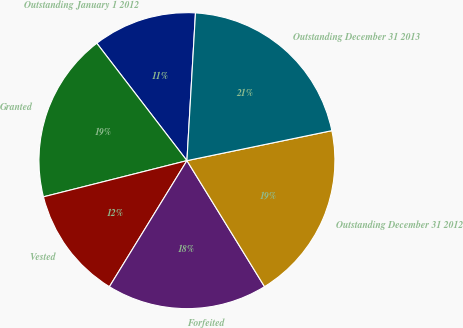<chart> <loc_0><loc_0><loc_500><loc_500><pie_chart><fcel>Outstanding January 1 2012<fcel>Granted<fcel>Vested<fcel>Forfeited<fcel>Outstanding December 31 2012<fcel>Outstanding December 31 2013<nl><fcel>11.34%<fcel>18.51%<fcel>12.29%<fcel>17.56%<fcel>19.46%<fcel>20.83%<nl></chart> 